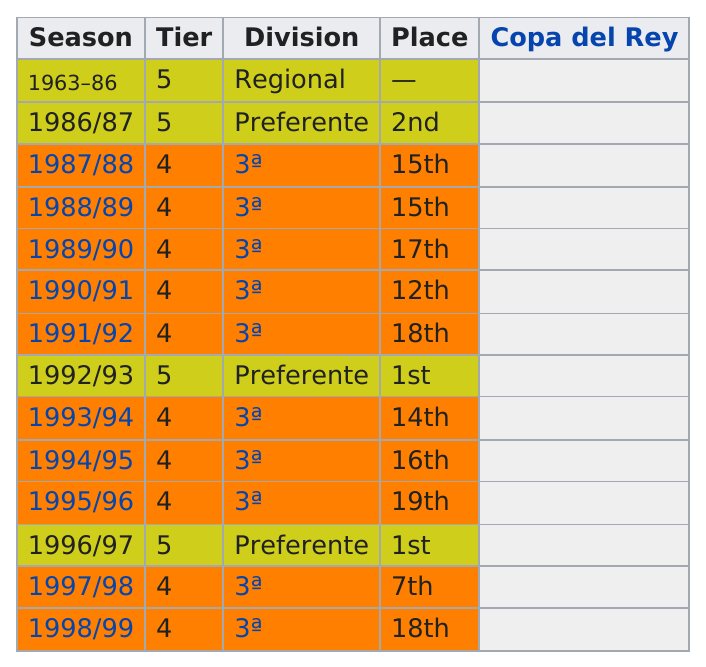List a handful of essential elements in this visual. The number of times that they placed first is 2. The 1996/1997 season was more successful than the 1995/1996 season. In every season except for 1998/99, the Chicago Blackhawks placed 18th in the standings. One example of such a season is 1991/92. SD Ponferradina B has finished better than fifth place on three occasions. The question is asking whether the performance of a certain team was better in the 1987/1988 or the 1993/1994 season. The 1993/1994 season is mentioned as an example. 